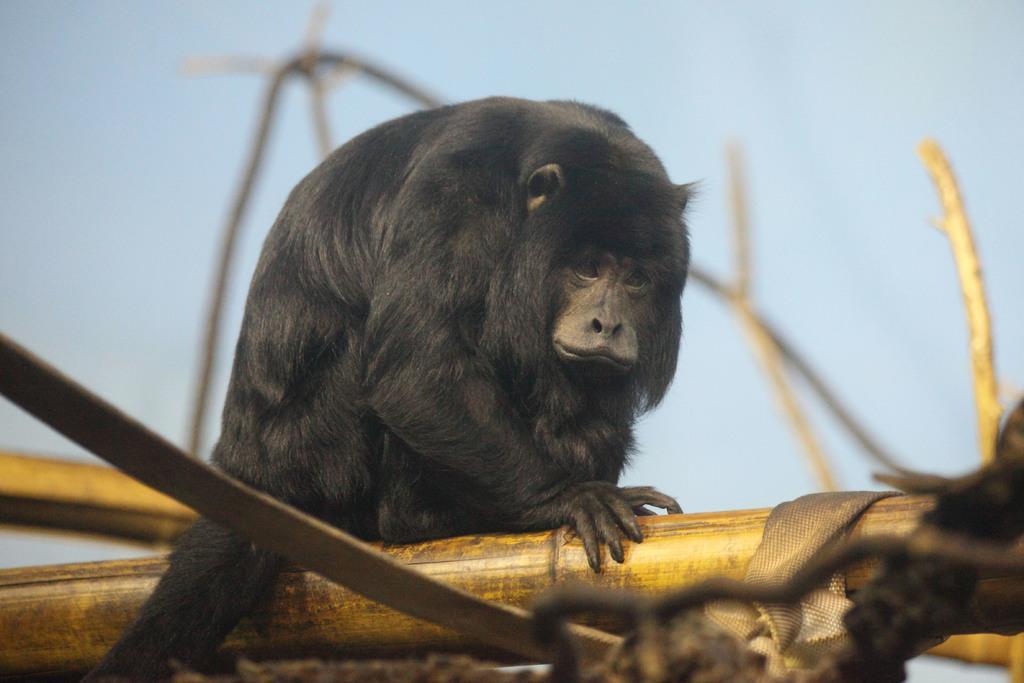Describe this image in one or two sentences. In this image we can see an animal on a wooden surface. Behind the animal we can see the sky. 